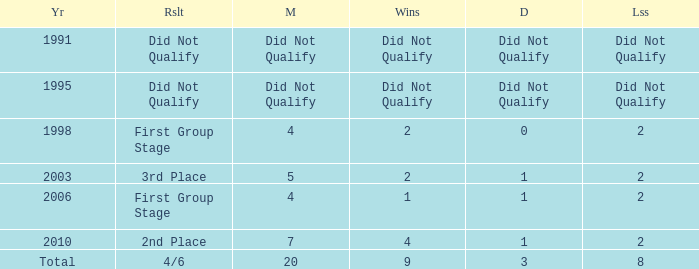Give me the full table as a dictionary. {'header': ['Yr', 'Rslt', 'M', 'Wins', 'D', 'Lss'], 'rows': [['1991', 'Did Not Qualify', 'Did Not Qualify', 'Did Not Qualify', 'Did Not Qualify', 'Did Not Qualify'], ['1995', 'Did Not Qualify', 'Did Not Qualify', 'Did Not Qualify', 'Did Not Qualify', 'Did Not Qualify'], ['1998', 'First Group Stage', '4', '2', '0', '2'], ['2003', '3rd Place', '5', '2', '1', '2'], ['2006', 'First Group Stage', '4', '1', '1', '2'], ['2010', '2nd Place', '7', '4', '1', '2'], ['Total', '4/6', '20', '9', '3', '8']]} How many draws were there in 2006? 1.0. 